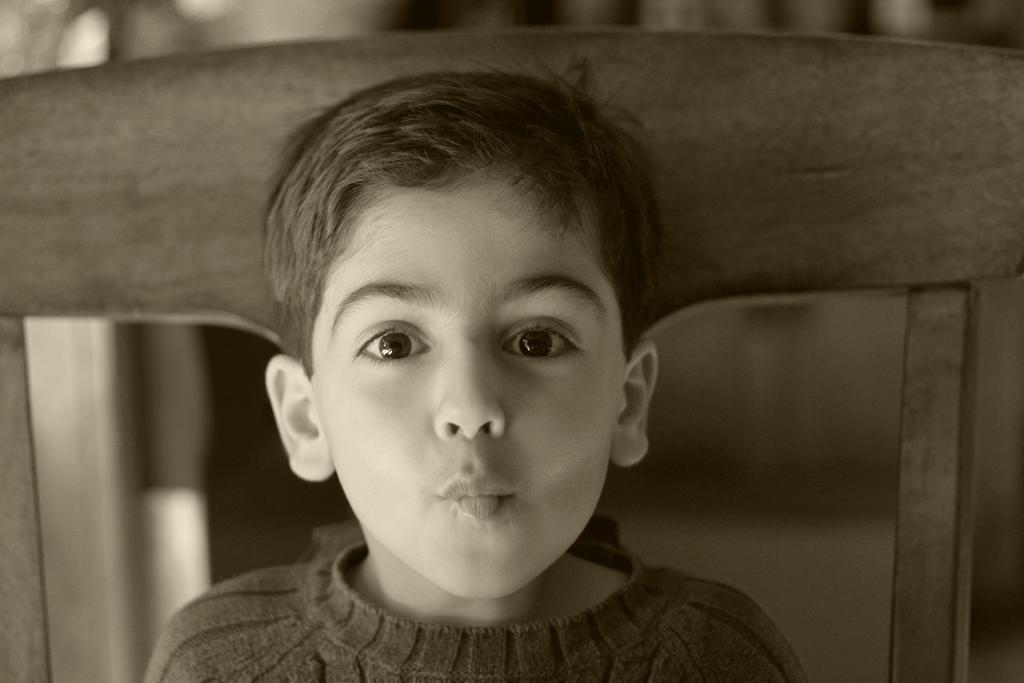Can you describe this image briefly? In this image I can see a boy is sitting on the chair. I can a black and white image. 